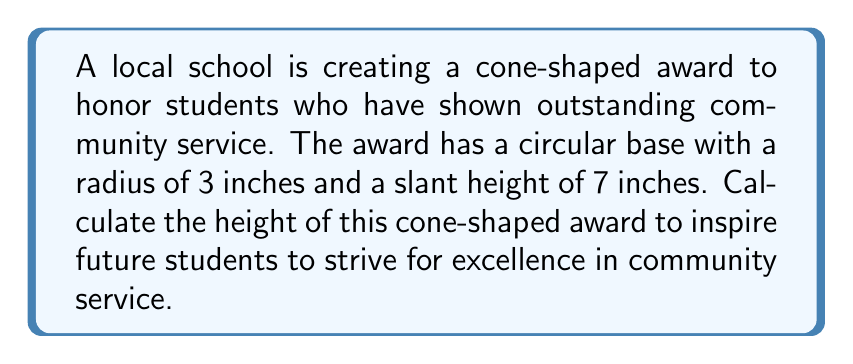Solve this math problem. To solve this problem, we'll use the Pythagorean theorem and the properties of a right triangle formed by the height, radius, and slant height of the cone.

1) Let's define our variables:
   $r$ = radius of the base = 3 inches
   $s$ = slant height = 7 inches
   $h$ = height of the cone (what we're solving for)

2) In a cone, the radius, height, and slant height form a right triangle. We can use the Pythagorean theorem:

   $$s^2 = r^2 + h^2$$

3) Substitute the known values:

   $$7^2 = 3^2 + h^2$$

4) Simplify:

   $$49 = 9 + h^2$$

5) Subtract 9 from both sides:

   $$40 = h^2$$

6) Take the square root of both sides:

   $$\sqrt{40} = h$$

7) Simplify the square root:

   $$h = 2\sqrt{10} \approx 6.32$$ inches

[asy]
import geometry;

size(100);
pair A = (0,0), B = (3,0), C = (0,6.32);
draw(A--B--C--A);
draw(B--(3,6.32),dashed);
label("3",(1.5,0),S);
label("7",(1.5,3.16),NE);
label("h",(0,3.16),W);
label("r",B,S);
[/asy]
Answer: The height of the cone-shaped award is $2\sqrt{10} \approx 6.32$ inches. 